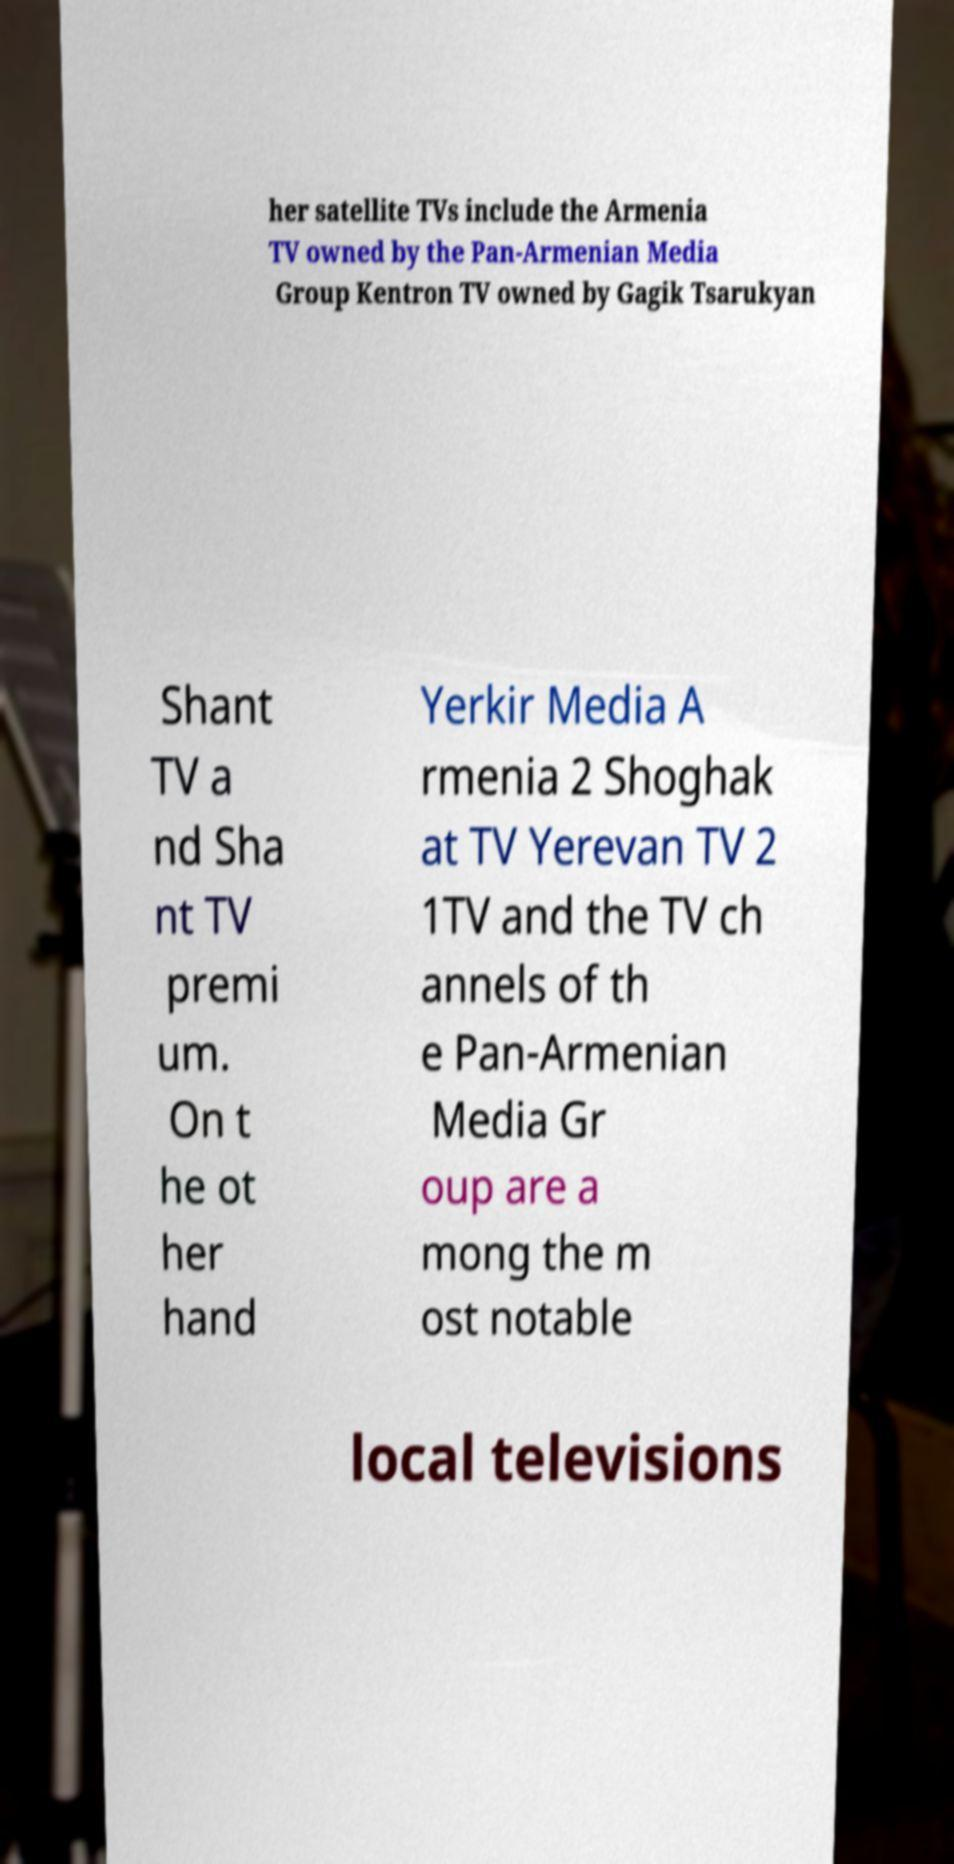For documentation purposes, I need the text within this image transcribed. Could you provide that? her satellite TVs include the Armenia TV owned by the Pan-Armenian Media Group Kentron TV owned by Gagik Tsarukyan Shant TV a nd Sha nt TV premi um. On t he ot her hand Yerkir Media A rmenia 2 Shoghak at TV Yerevan TV 2 1TV and the TV ch annels of th e Pan-Armenian Media Gr oup are a mong the m ost notable local televisions 